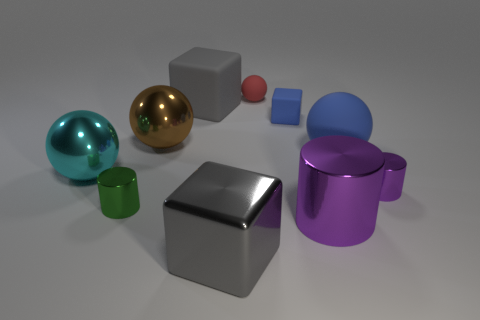There is a cylinder that is the same size as the green object; what is it made of?
Your answer should be very brief. Metal. How many other things are made of the same material as the large purple thing?
Your answer should be compact. 5. There is a sphere that is in front of the red object and on the right side of the shiny block; what color is it?
Your answer should be very brief. Blue. What number of objects are cubes in front of the small green cylinder or small metallic things?
Give a very brief answer. 3. What number of other objects are there of the same color as the big matte cube?
Provide a short and direct response. 1. Are there the same number of purple metal cylinders behind the tiny green cylinder and metallic cubes?
Your answer should be very brief. Yes. What number of blue objects are in front of the gray object that is behind the purple thing that is right of the big blue rubber object?
Make the answer very short. 2. There is a red rubber sphere; does it have the same size as the shiny ball in front of the large blue sphere?
Your answer should be very brief. No. How many big shiny cubes are there?
Your response must be concise. 1. There is a blue matte thing in front of the blue block; is its size the same as the gray cube behind the big metallic cylinder?
Your answer should be very brief. Yes. 